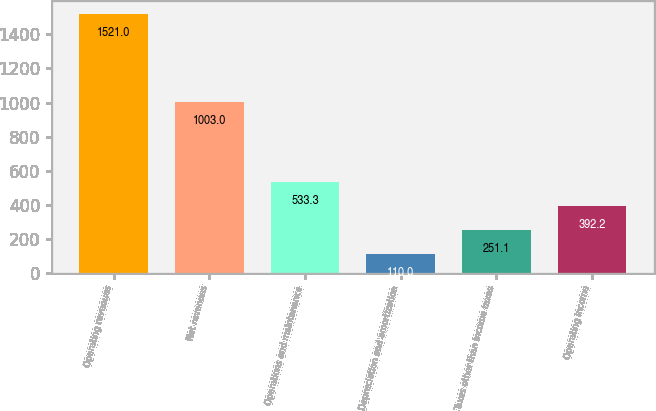Convert chart to OTSL. <chart><loc_0><loc_0><loc_500><loc_500><bar_chart><fcel>Operating revenues<fcel>Net revenues<fcel>Operations and maintenance<fcel>Depreciation and amortization<fcel>Taxes other than income taxes<fcel>Operating income<nl><fcel>1521<fcel>1003<fcel>533.3<fcel>110<fcel>251.1<fcel>392.2<nl></chart> 